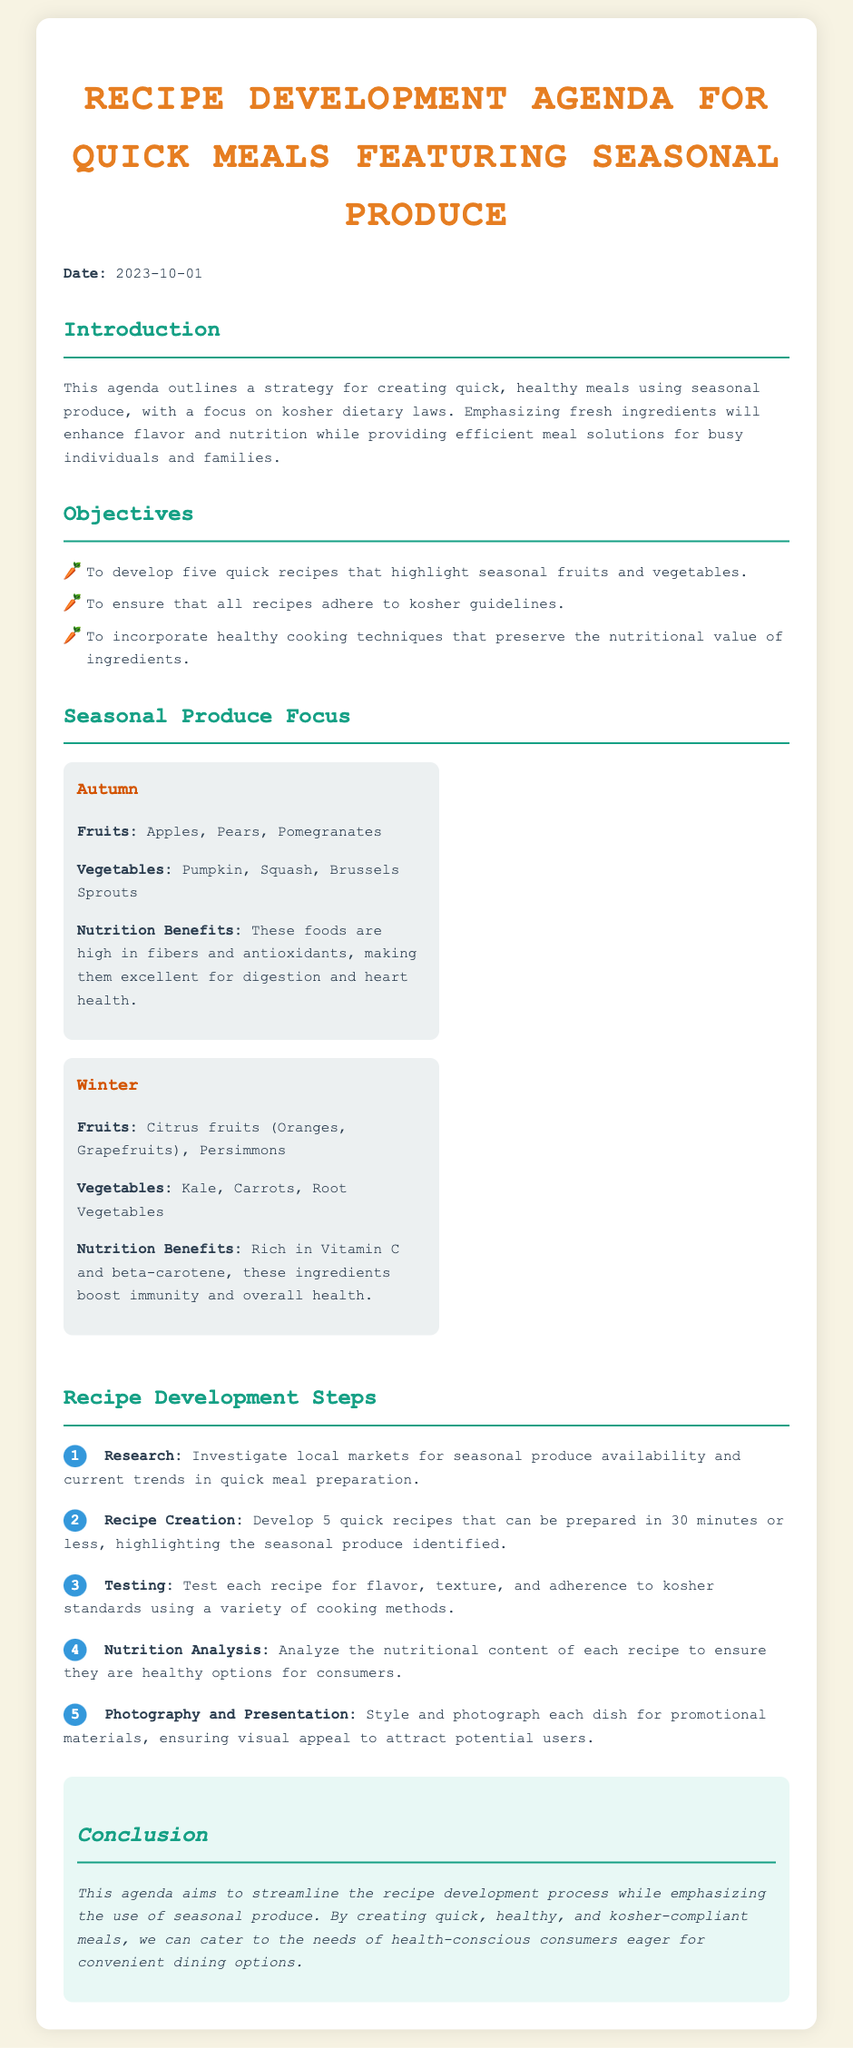What is the date of the agenda? The date is explicitly mentioned at the beginning of the document as 2023-10-01.
Answer: 2023-10-01 How many quick recipes are to be developed? The objectives section states that the aim is to develop five quick recipes.
Answer: five What are the fruits listed for Autumn? The document outlines the seasonal produce, specifically listing Apples, Pears, and Pomegranates under Autumn fruits.
Answer: Apples, Pears, Pomegranates What cooking method is mentioned in the testing step? The testing step mentions using a variety of cooking methods to evaluate the recipes.
Answer: variety of cooking methods Which season's vegetables include Kale? The document mentions Kale under the Winter seasonal produce section.
Answer: Winter What is the main focus of the conclusion? The conclusion emphasizes streamlining the recipe development process while using seasonal produce.
Answer: seasonal produce What are the two objectives mentioned in the agenda? The objectives specifically include developing quick recipes and ensuring they abide by kosher guidelines.
Answer: quick recipes and kosher guidelines Which two nutritional benefits are highlighted for the Winter vegetables? The Winter vegetables are noted for being rich in Vitamin C and beta-carotene.
Answer: Vitamin C and beta-carotene What visual appeal aspect is part of the recipe development steps? The photography and presentation step highlights the importance of styling each dish to enhance its visual appeal.
Answer: visual appeal 